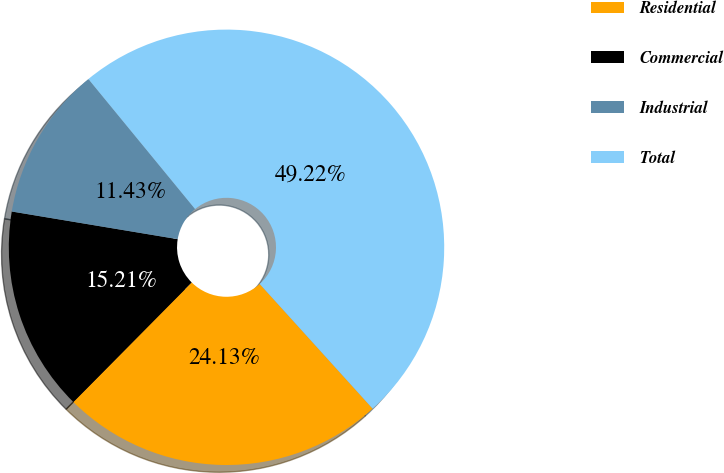<chart> <loc_0><loc_0><loc_500><loc_500><pie_chart><fcel>Residential<fcel>Commercial<fcel>Industrial<fcel>Total<nl><fcel>24.13%<fcel>15.21%<fcel>11.43%<fcel>49.22%<nl></chart> 